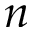Convert formula to latex. <formula><loc_0><loc_0><loc_500><loc_500>n</formula> 